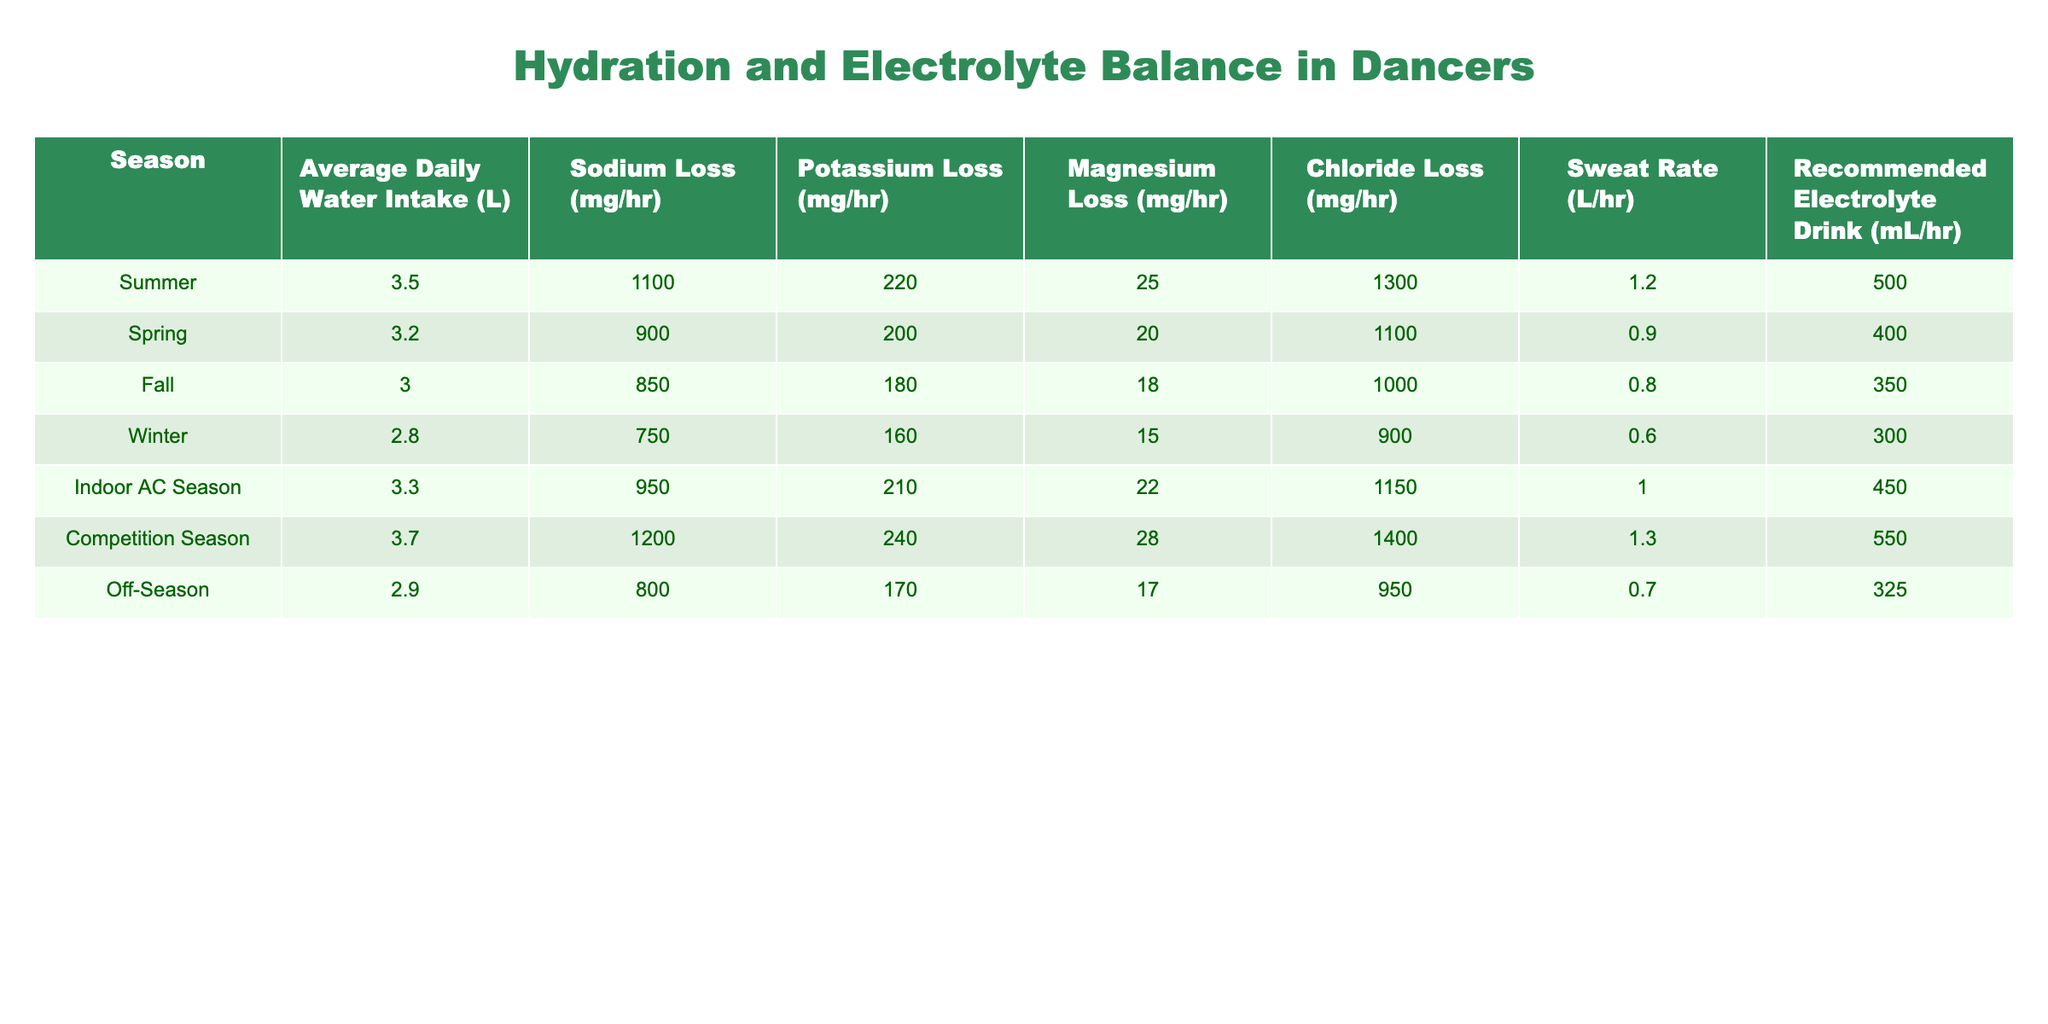What is the average daily water intake in summer? The table lists the average daily water intake for each season. For summer, the specified value is 3.5 L.
Answer: 3.5 L Which season has the highest sodium loss? Looking at the sodium loss column, summer has the highest value at 1100 mg/hr.
Answer: Summer What is the difference in potassium loss between spring and winter? From the table, the potassium loss in spring is 200 mg/hr, while in winter it is 160 mg/hr. The difference is 200 - 160 = 40 mg/hr.
Answer: 40 mg/hr Is the recommended electrolyte drink for competitions higher than for fall? The recommended electrolyte drink for competition season is 550 mL/hr, and for fall it is 350 mL/hr. Since 550 is greater than 350, the statement is true.
Answer: Yes What is the average sweat rate during indoor AC season and winter? The sweat rate for indoor AC season is 1.0 L/hr, and for winter it is 0.6 L/hr. The average is (1.0 + 0.6) / 2 = 0.8 L/hr.
Answer: 0.8 L/hr What is the total sodium loss for summer and competition season combined? Sodium loss for summer is 1100 mg/hr, and for competition season, it is 1200 mg/hr. Adding them gives 1100 + 1200 = 2300 mg/hr.
Answer: 2300 mg/hr In which season does the highest sweat rate occur? The sweat rate is highest in competition season at 1.3 L/hr, which is verified from the sweat rate column.
Answer: Competition Season Is the average daily water intake in off-season lower than that in winter? Off-season intake is 2.9 L and winter intake is 2.8 L. Therefore, off-season is higher than winter, making the statement false.
Answer: No What is the difference in chloride loss between summer and fall? Chloride loss in summer is 1300 mg/hr and in fall is 1000 mg/hr. The difference is 1300 - 1000 = 300 mg/hr.
Answer: 300 mg/hr 